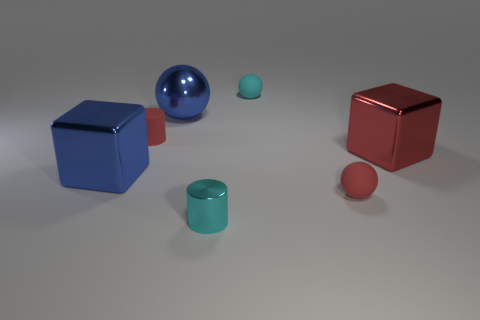Add 1 large red shiny objects. How many objects exist? 8 Subtract all cyan cylinders. How many cylinders are left? 1 Subtract all small balls. How many balls are left? 1 Subtract all green blocks. Subtract all green spheres. How many blocks are left? 2 Subtract all gray cylinders. How many green cubes are left? 0 Subtract all metal cylinders. Subtract all matte cylinders. How many objects are left? 5 Add 1 tiny red rubber spheres. How many tiny red rubber spheres are left? 2 Add 6 cyan things. How many cyan things exist? 8 Subtract 0 green spheres. How many objects are left? 7 Subtract all cylinders. How many objects are left? 5 